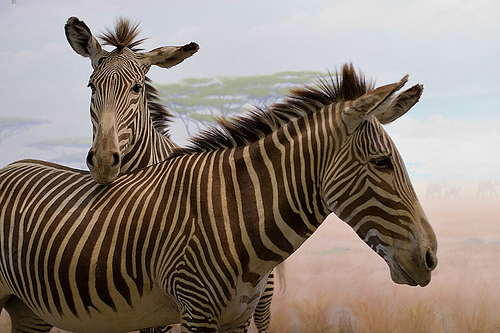Please provide a short description for this region: [0.38, 0.3, 0.56, 0.41]. This area captures a pale-colored tree standing behind the zebras, giving a subtle contrast to the vivid striping of the animals and adding depth to the scene. 